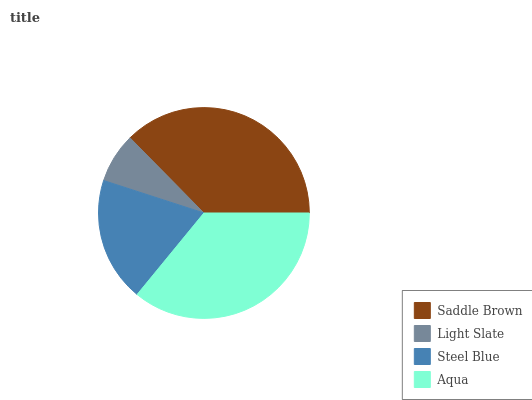Is Light Slate the minimum?
Answer yes or no. Yes. Is Saddle Brown the maximum?
Answer yes or no. Yes. Is Steel Blue the minimum?
Answer yes or no. No. Is Steel Blue the maximum?
Answer yes or no. No. Is Steel Blue greater than Light Slate?
Answer yes or no. Yes. Is Light Slate less than Steel Blue?
Answer yes or no. Yes. Is Light Slate greater than Steel Blue?
Answer yes or no. No. Is Steel Blue less than Light Slate?
Answer yes or no. No. Is Aqua the high median?
Answer yes or no. Yes. Is Steel Blue the low median?
Answer yes or no. Yes. Is Saddle Brown the high median?
Answer yes or no. No. Is Light Slate the low median?
Answer yes or no. No. 